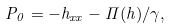<formula> <loc_0><loc_0><loc_500><loc_500>P _ { 0 } = - h _ { x x } - \Pi ( h ) / \gamma ,</formula> 